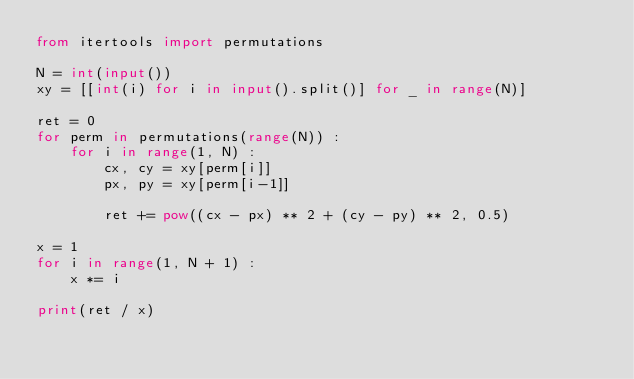Convert code to text. <code><loc_0><loc_0><loc_500><loc_500><_Python_>from itertools import permutations

N = int(input())
xy = [[int(i) for i in input().split()] for _ in range(N)]

ret = 0
for perm in permutations(range(N)) :
    for i in range(1, N) :
        cx, cy = xy[perm[i]]
        px, py = xy[perm[i-1]]
        
        ret += pow((cx - px) ** 2 + (cy - py) ** 2, 0.5)

x = 1
for i in range(1, N + 1) :
    x *= i
    
print(ret / x)</code> 